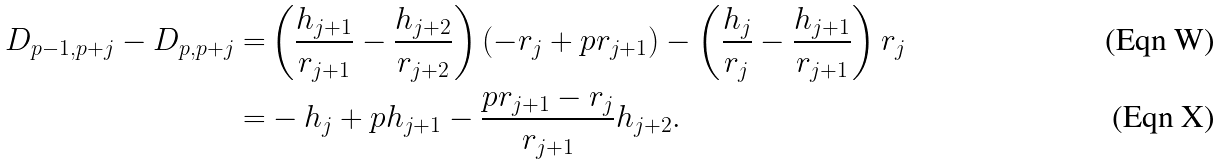Convert formula to latex. <formula><loc_0><loc_0><loc_500><loc_500>D _ { p - 1 , p + j } - D _ { p , p + j } = & \left ( \frac { h _ { j + 1 } } { r _ { j + 1 } } - \frac { h _ { j + 2 } } { r _ { j + 2 } } \right ) ( - r _ { j } + p r _ { j + 1 } ) - \left ( \frac { h _ { j } } { r _ { j } } - \frac { h _ { j + 1 } } { r _ { j + 1 } } \right ) r _ { j } \\ = & - h _ { j } + p h _ { j + 1 } - \frac { p r _ { j + 1 } - r _ { j } } { r _ { j + 1 } } h _ { j + 2 } .</formula> 